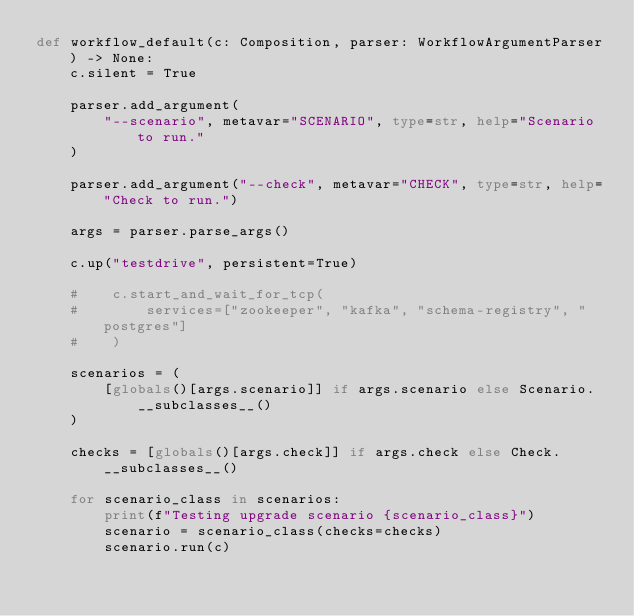<code> <loc_0><loc_0><loc_500><loc_500><_Python_>def workflow_default(c: Composition, parser: WorkflowArgumentParser) -> None:
    c.silent = True

    parser.add_argument(
        "--scenario", metavar="SCENARIO", type=str, help="Scenario to run."
    )

    parser.add_argument("--check", metavar="CHECK", type=str, help="Check to run.")

    args = parser.parse_args()

    c.up("testdrive", persistent=True)

    #    c.start_and_wait_for_tcp(
    #        services=["zookeeper", "kafka", "schema-registry", "postgres"]
    #    )

    scenarios = (
        [globals()[args.scenario]] if args.scenario else Scenario.__subclasses__()
    )

    checks = [globals()[args.check]] if args.check else Check.__subclasses__()

    for scenario_class in scenarios:
        print(f"Testing upgrade scenario {scenario_class}")
        scenario = scenario_class(checks=checks)
        scenario.run(c)
</code> 